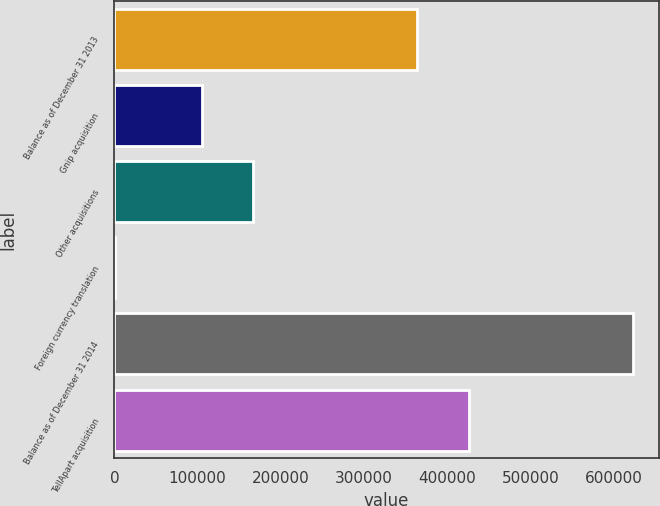Convert chart. <chart><loc_0><loc_0><loc_500><loc_500><bar_chart><fcel>Balance as of December 31 2013<fcel>Gnip acquisition<fcel>Other acquisitions<fcel>Foreign currency translation<fcel>Balance as of December 31 2014<fcel>TellApart acquisition<nl><fcel>363477<fcel>104747<fcel>166933<fcel>708<fcel>622570<fcel>425663<nl></chart> 